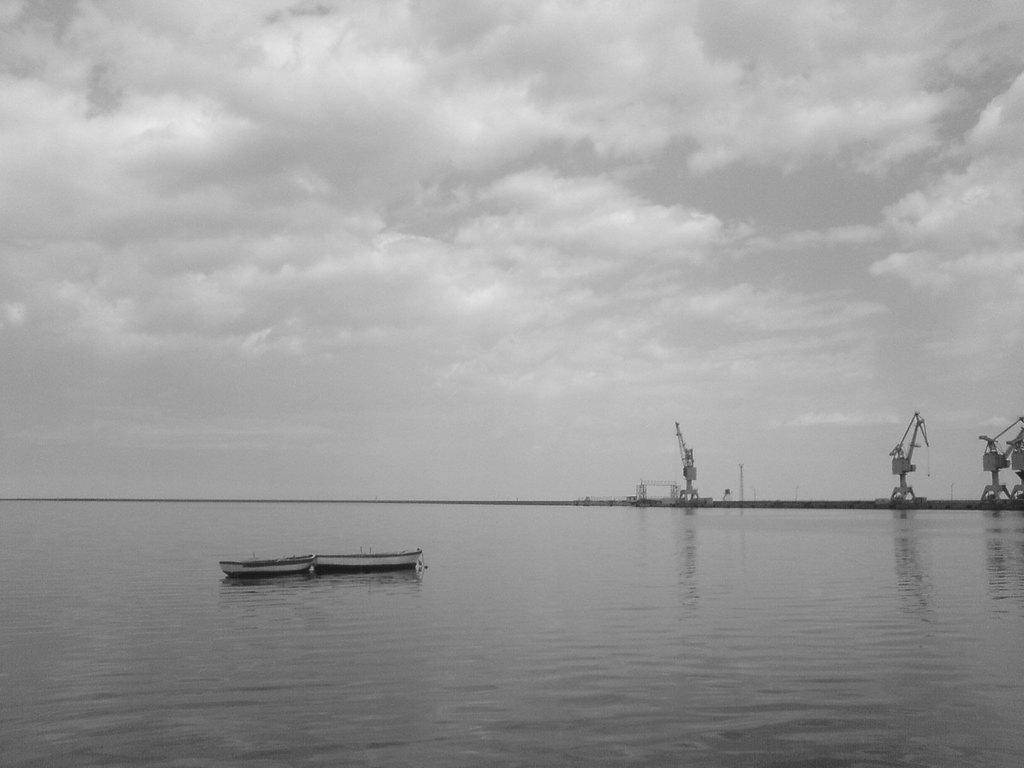What can be seen floating in the water in the image? There are two boats in the water in the image. What structures are present on the land in the image? There are cranes on the land in the image. What natural feature is visible in the background of the image? The background of the image includes the ocean. What is visible at the top of the image? The sky is visible at the top of the image, and clouds are present in the sky. What type of scent can be detected in the image? There is no information about scents in the image, so it cannot be determined from the image. What type of market is visible in the image? There is no market present in the image; it features two boats in the water and cranes on the land. 